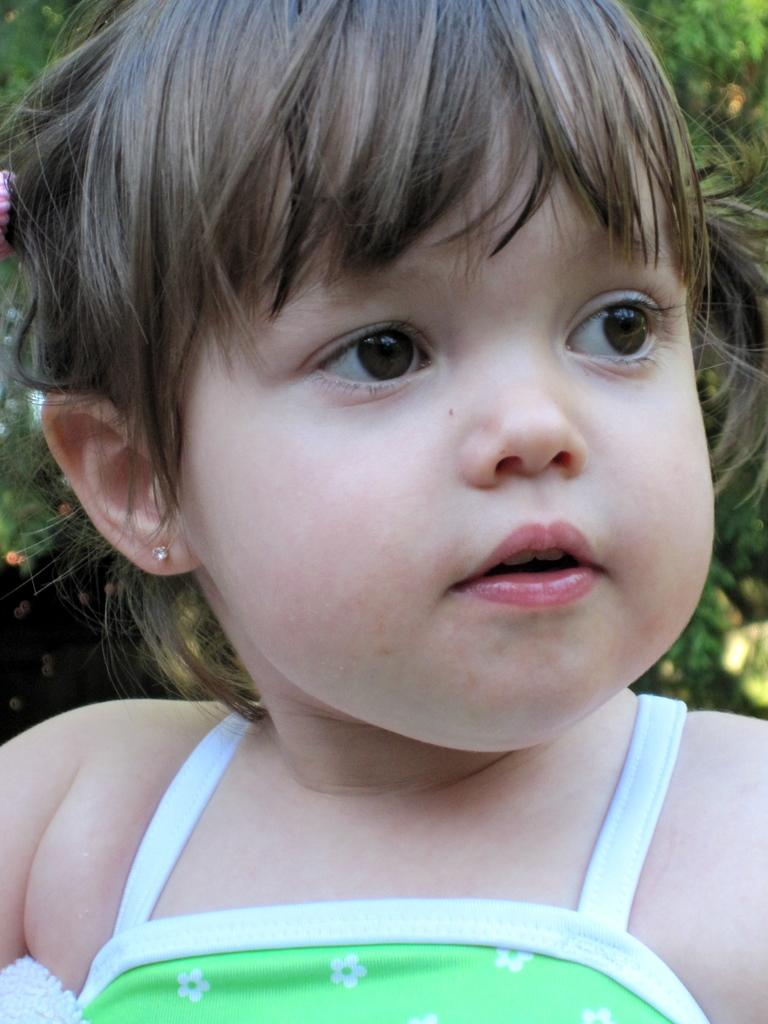What is the main subject of the image? There is a baby in the image. What can be seen in the background of the image? There are trees in the background of the image. How many dogs are present in the image? There are no dogs present in the image; it features a baby and trees in the background. What type of currency is visible in the image? There is no currency present in the image. 